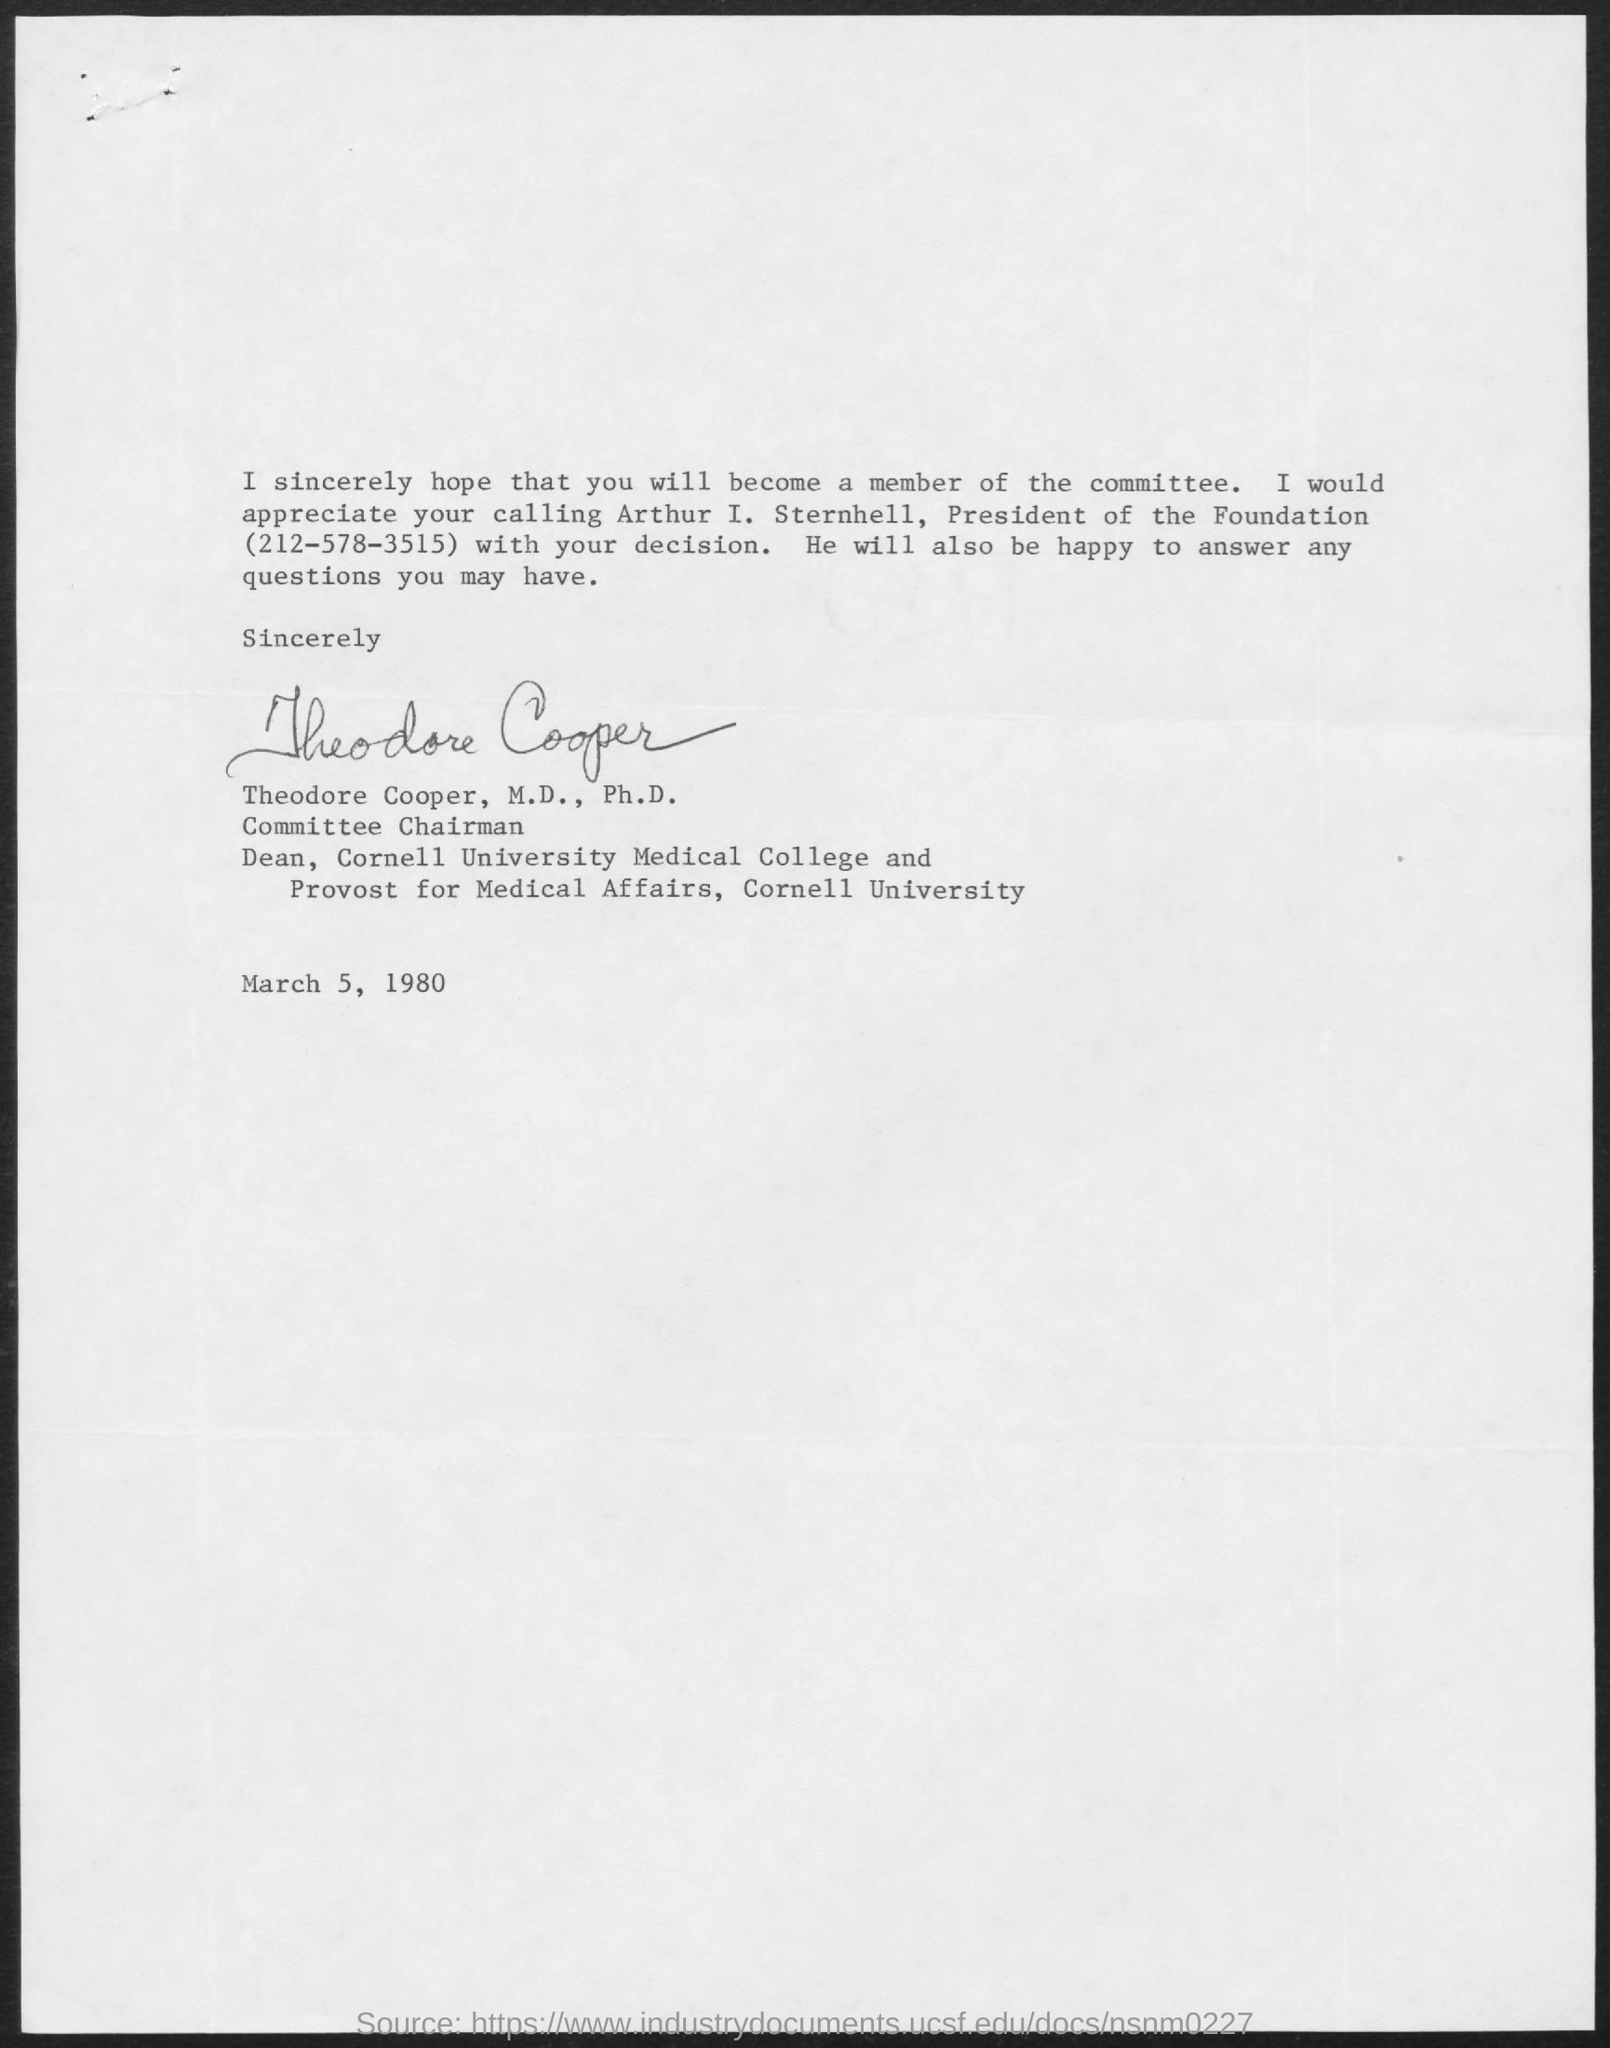Who is the President of the foundation?
Keep it short and to the point. Arthur I. Sternhell. What is the date on the document?
Your response must be concise. March 5, 1980. Who is this letter from?
Give a very brief answer. Theodore Cooper, M.D., Ph.D. 